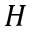Convert formula to latex. <formula><loc_0><loc_0><loc_500><loc_500>H</formula> 